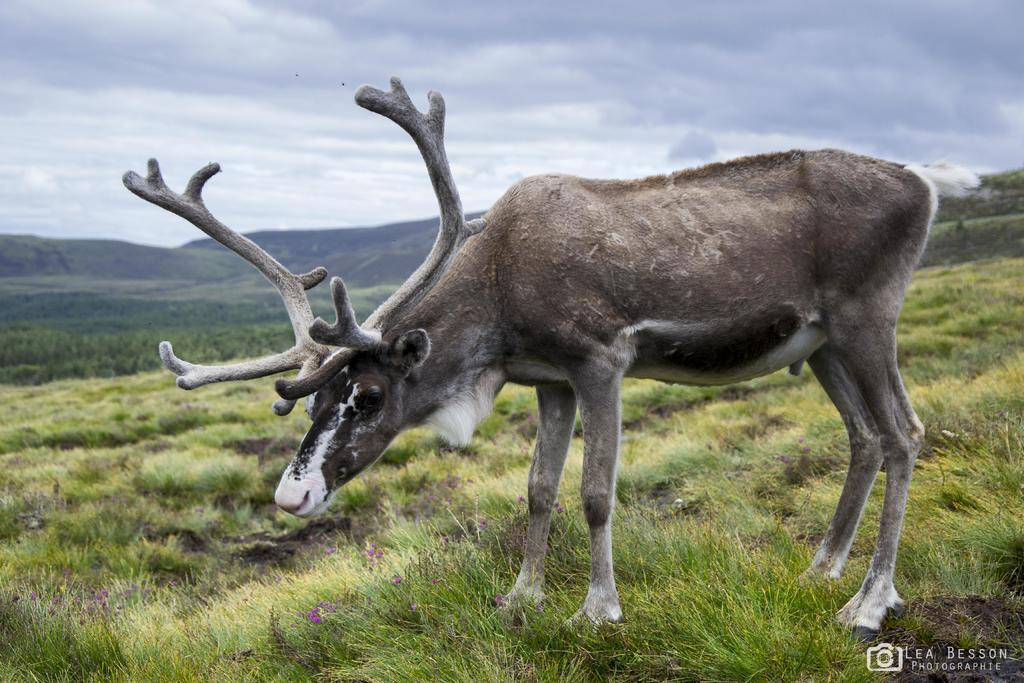What is the main subject in the front of the image? There is an animal in the front of the image. What type of vegetation can be seen on the ground in the background? There is grass on the ground in the background of the image. What other natural features are visible in the background? There are trees and mountains in the background of the image. How would you describe the sky in the image? The sky is cloudy in the image. What verse is being recited by the animal in the image? There is no indication in the image that the animal is reciting a verse, so it cannot be determined from the picture. 